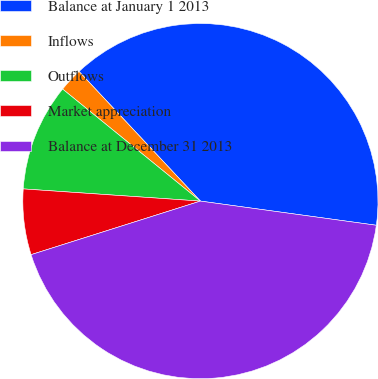Convert chart. <chart><loc_0><loc_0><loc_500><loc_500><pie_chart><fcel>Balance at January 1 2013<fcel>Inflows<fcel>Outflows<fcel>Market appreciation<fcel>Balance at December 31 2013<nl><fcel>39.15%<fcel>2.16%<fcel>9.77%<fcel>5.97%<fcel>42.95%<nl></chart> 